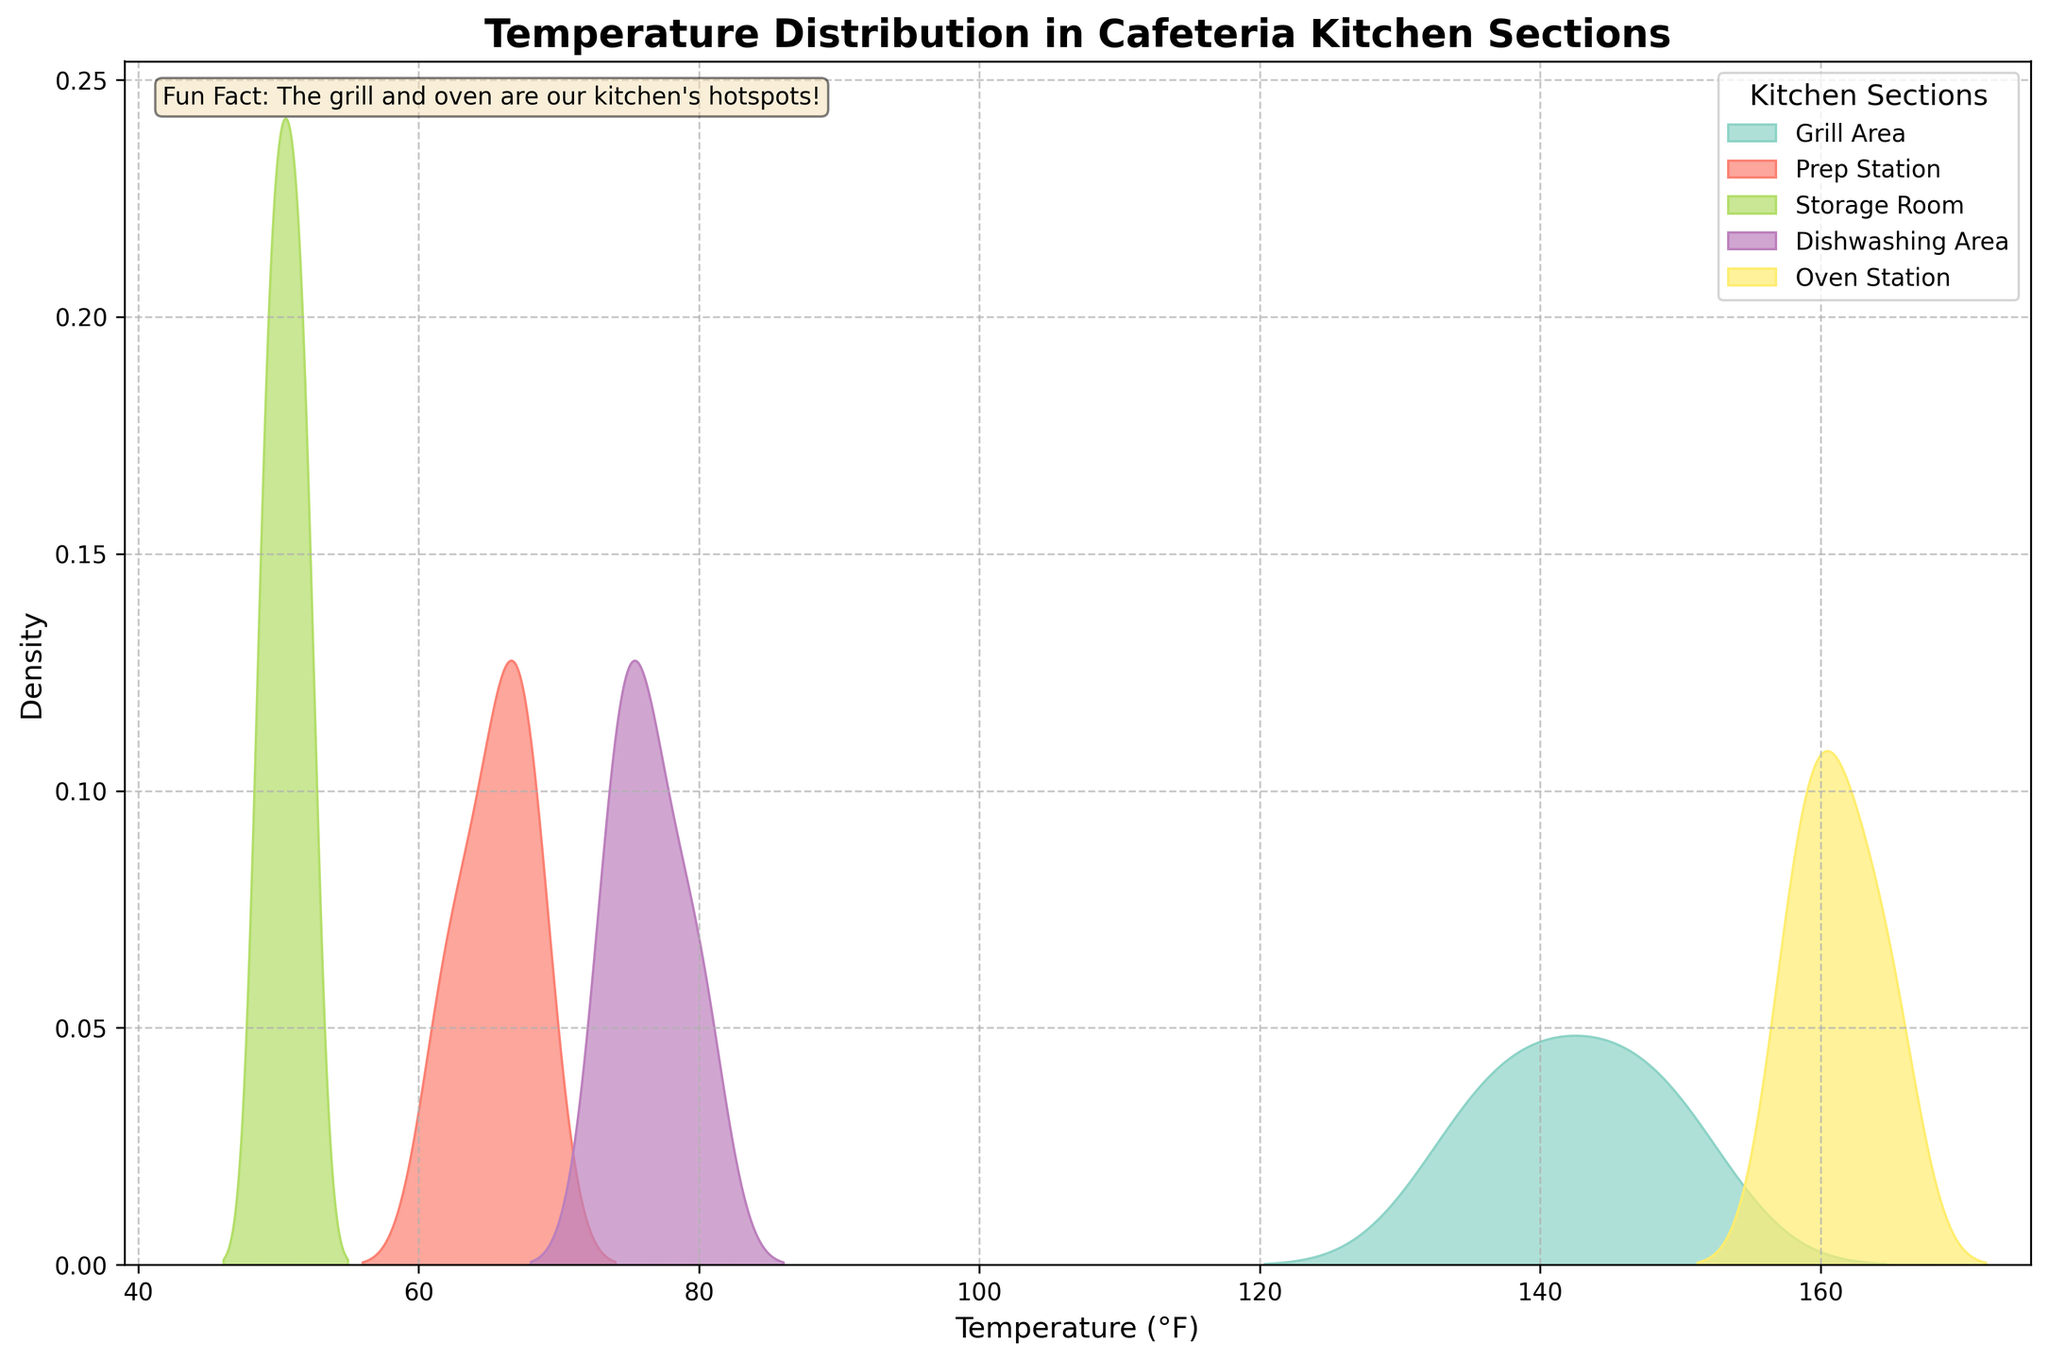What is the title of the figure? The title can be found at the top of the figure. It indicates the main subject or theme of the plot.
Answer: Temperature Distribution in Cafeteria Kitchen Sections What does the x-axis represent? The x-axis is labeled and shows the range of values it represents.
Answer: Temperature (°F) Which section has the highest peak density in the temperature distribution? Look for the peak that reaches the highest on the y-axis and check the label in the legend that corresponds to it.
Answer: Oven Station How many different kitchen sections are shown in the figure? Count the number of unique colors with labels in the legend on the right side of the plot.
Answer: 5 In which section is the temperature range the narrowest throughout the day? Observe the width of the curves for each section; the narrowest curve represents the section with the least variation in temperature.
Answer: Storage Room Which kitchen section shows the greatest variation in temperature? Identify the section with the widest spread in its distribution curve on the x-axis.
Answer: Grill Area What is the approximate temperature range for the Prep Station? Check the distribution curve for the Prep Station and note the range it covers on the x-axis.
Answer: Approximately 60°F to 70°F Compare the Grill Area and the Dishwashing Area, which one has a higher average temperature? Without computing the exact mean, we can visually compare the shifts of the peaks of the curves. The curve shifted further to the right indicates higher average temperature.
Answer: Grill Area What is the fun fact mentioned in the figure? Look at the text box added to the plot, typically placed within the plot area.
Answer: The grill and oven are our kitchen's hotspots! 